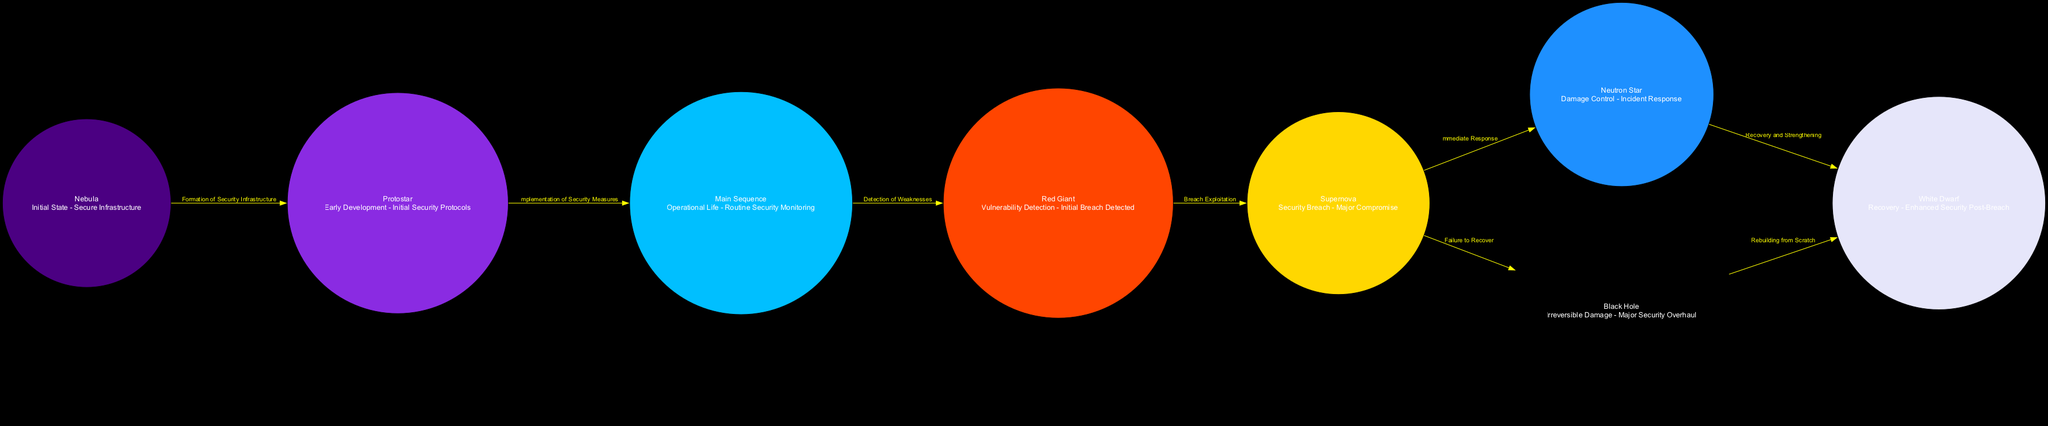What is the label of the node corresponding to "Initial State"? In the diagram, the node labeled "Nebula" represents the "Initial State - Secure Infrastructure." Thus, the answer can be derived directly from the description provided for this node.
Answer: Nebula How many total nodes are present in this diagram? The diagram lists a total of eight nodes, which represent different stages of the lifecycle and their metaphorical meanings relating to security breaches and recovery. Therefore, counting each node gives the answer.
Answer: 8 Which node comes after "Red Giant"? From the diagram's flow, the edge directed from "Red Giant" leads to the "Supernova" node, indicating that this is the next stage in the lifecycle sequence.
Answer: Supernova What color is the "Neutron Star" node? According to the color scheme provided, the "Neutron Star" is represented using the color "Dodger Blue." This information is directly referenced from the color mapping for this specific node.
Answer: Dodger Blue What relationship does "Main Sequence" have with "Red Giant"? The relationship indicated by the edge between "Main Sequence" and "Red Giant" is labeled "Detection of Weaknesses," which shows how the operational life leads to identifying vulnerabilities. This relationship can be directly read from the diagram.
Answer: Detection of Weaknesses What happens after a "Supernova"? The diagram details two possible outcomes following a "Supernova": an immediate response leading to a "Neutron Star" or a failure to recover resulting in a "Black Hole." This indicates the decision point in the progression from a major breach.
Answer: Neutron Star, Black Hole What stage represents "Enhanced Security Post-Breach"? The final recovery phase is represented by the "White Dwarf," which is described as "Recovery - Enhanced Security Post-Breach." Thus, the diagram explicitly states this as the stage of recovery.
Answer: White Dwarf Which node signifies "Irreversible Damage"? The node labeled "Black Hole" corresponds to "Irreversible Damage - Major Security Overhaul." This is clearly defined in the node's description, allowing for a straightforward identification.
Answer: Black Hole 